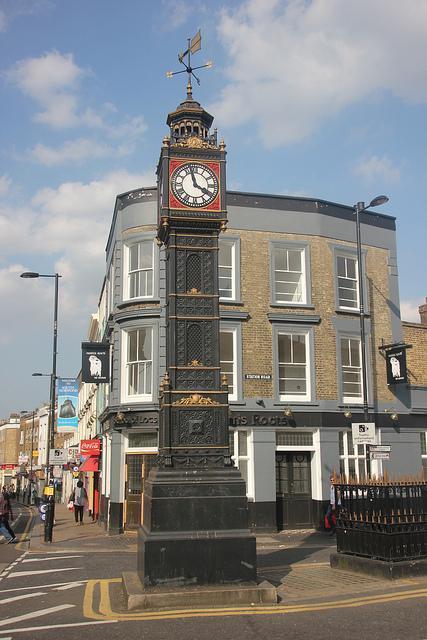This street is located where?
Make your selection from the four choices given to correctly answer the question.
Options: Field, suburb, city, desert. City. 